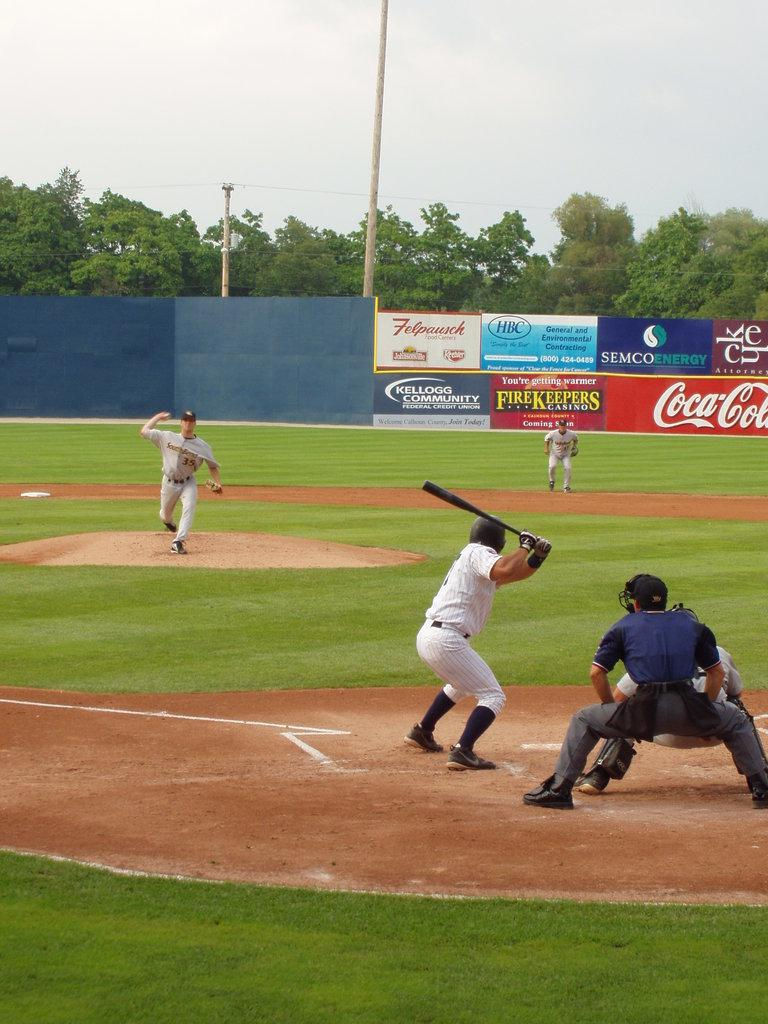Provide a one-sentence caption for the provided image. A baseball game is being played in a stadium at has a banner up for Coca-Cola. 